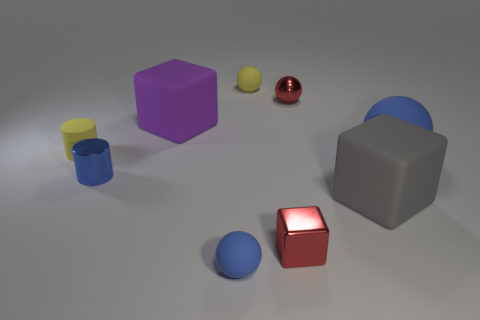There is a purple rubber object; does it have the same size as the cylinder in front of the large blue matte sphere?
Your response must be concise. No. Is the size of the yellow rubber cylinder the same as the purple matte thing?
Provide a succinct answer. No. Is the shape of the purple thing the same as the big gray rubber thing?
Ensure brevity in your answer.  Yes. What size is the other rubber thing that is the same shape as the large gray matte object?
Provide a succinct answer. Large. What shape is the large thing that is behind the blue object behind the tiny blue metal cylinder?
Provide a short and direct response. Cube. What size is the metal ball?
Your response must be concise. Small. What shape is the large purple matte thing?
Your answer should be compact. Cube. Is the shape of the gray matte object the same as the tiny yellow thing that is right of the small blue rubber ball?
Ensure brevity in your answer.  No. There is a blue matte object to the left of the gray rubber cube; does it have the same shape as the blue metallic thing?
Provide a succinct answer. No. What number of tiny objects are both on the left side of the metal block and behind the small yellow cylinder?
Give a very brief answer. 1. 